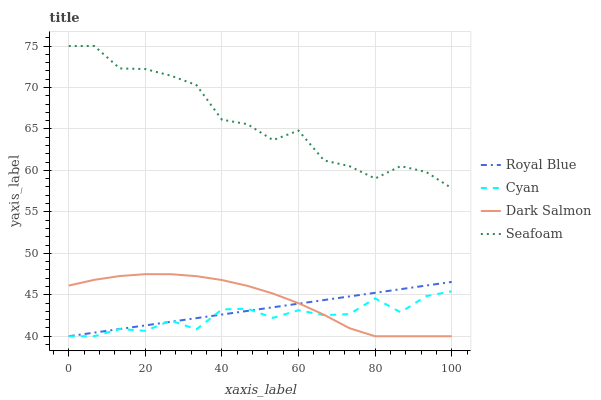Does Dark Salmon have the minimum area under the curve?
Answer yes or no. No. Does Dark Salmon have the maximum area under the curve?
Answer yes or no. No. Is Dark Salmon the smoothest?
Answer yes or no. No. Is Dark Salmon the roughest?
Answer yes or no. No. Does Seafoam have the lowest value?
Answer yes or no. No. Does Dark Salmon have the highest value?
Answer yes or no. No. Is Cyan less than Seafoam?
Answer yes or no. Yes. Is Seafoam greater than Dark Salmon?
Answer yes or no. Yes. Does Cyan intersect Seafoam?
Answer yes or no. No. 